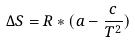Convert formula to latex. <formula><loc_0><loc_0><loc_500><loc_500>\Delta S = R * ( a - \frac { c } { T ^ { 2 } } )</formula> 